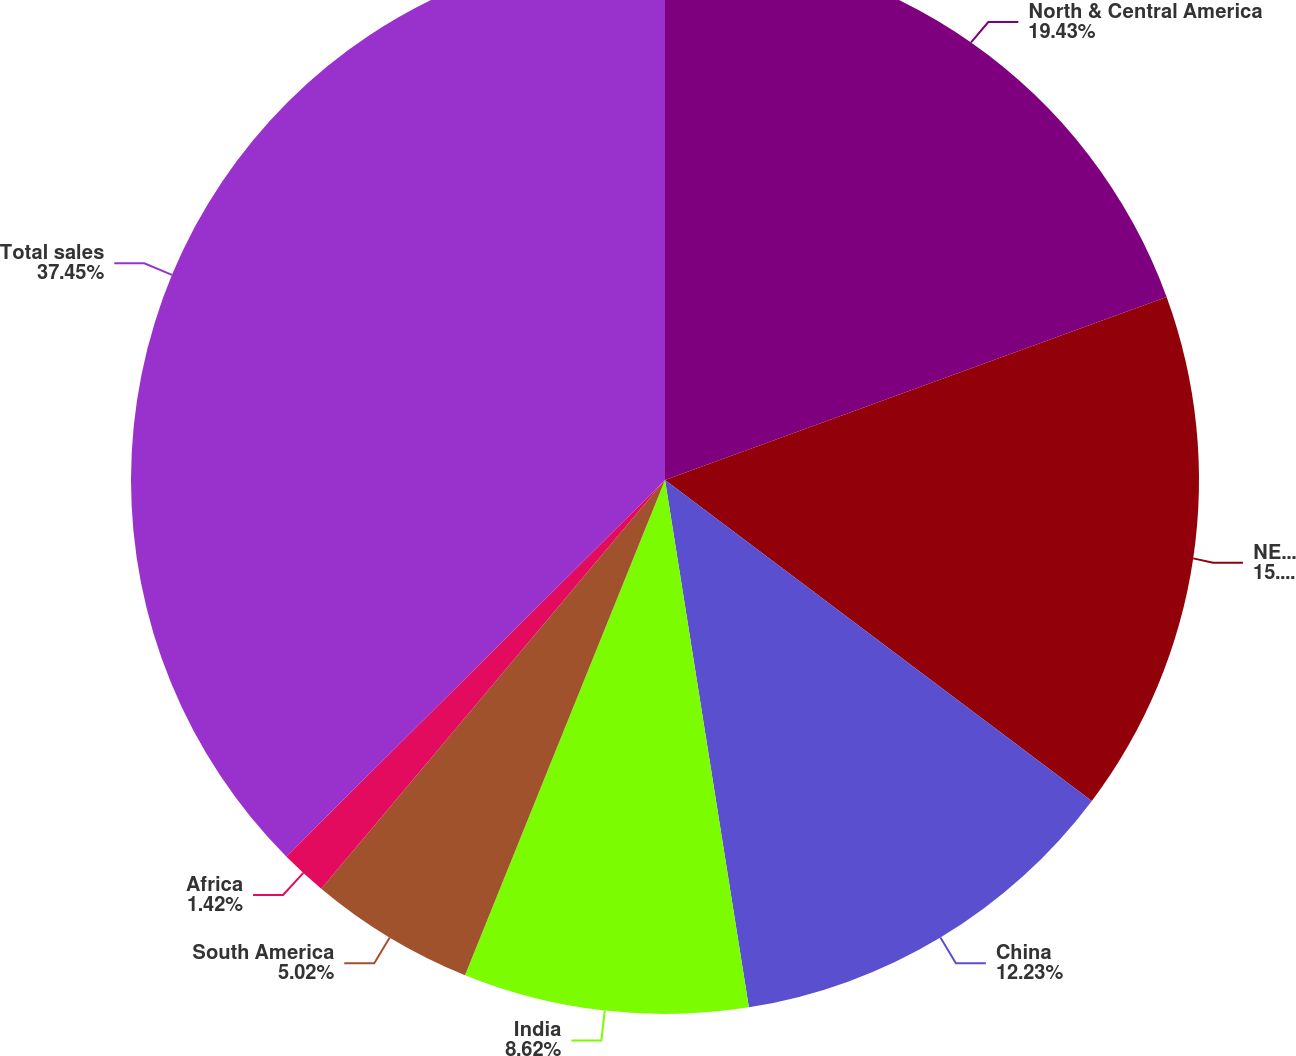<chart> <loc_0><loc_0><loc_500><loc_500><pie_chart><fcel>North & Central America<fcel>NE/SE Asia / South Pacific<fcel>China<fcel>India<fcel>South America<fcel>Africa<fcel>Total sales<nl><fcel>19.43%<fcel>15.83%<fcel>12.23%<fcel>8.62%<fcel>5.02%<fcel>1.42%<fcel>37.45%<nl></chart> 